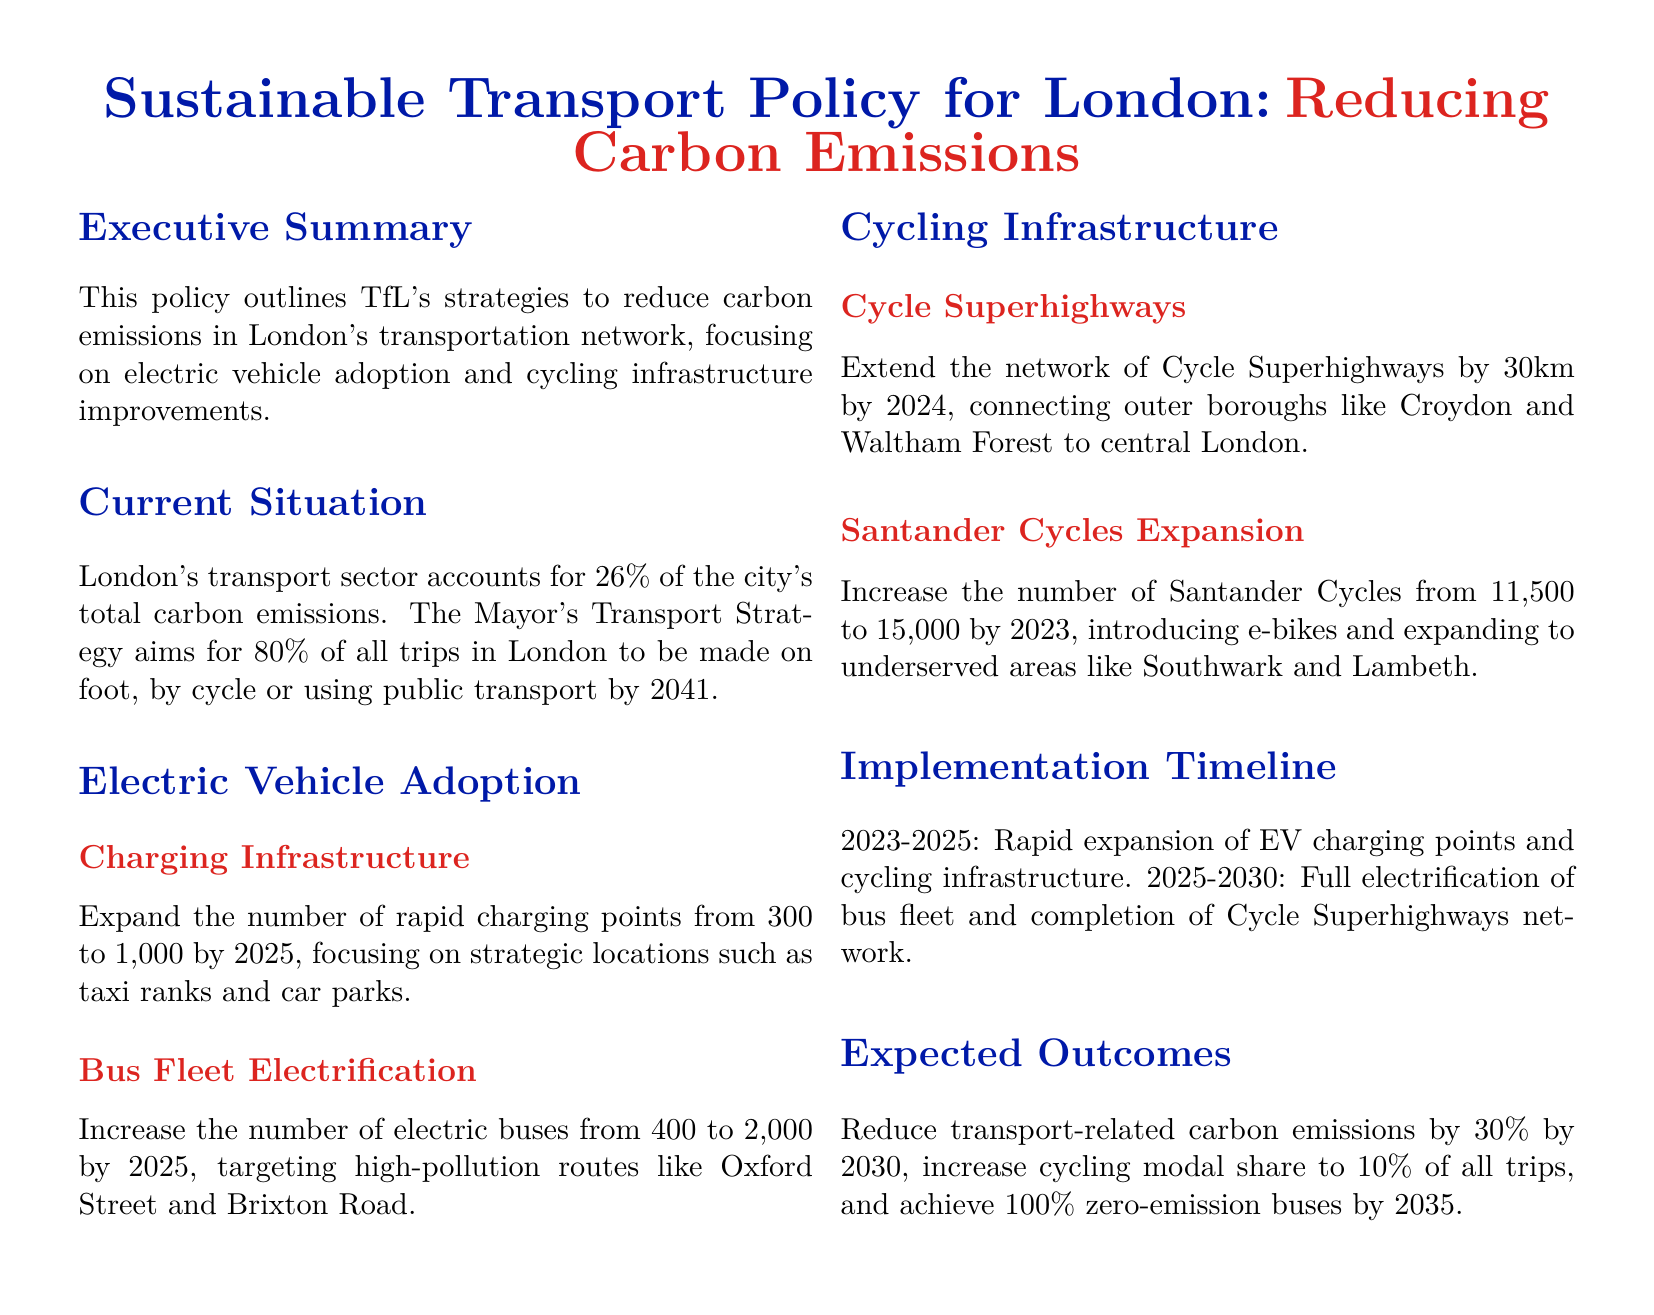What percentage of London's carbon emissions comes from the transport sector? The document states that London's transport sector accounts for 26% of the city's total carbon emissions.
Answer: 26% What is the target for electric buses by 2025? The policy aims to increase the number of electric buses from 400 to 2,000 by 2025.
Answer: 2,000 By how many kilometers will the Cycle Superhighways network be extended by 2024? The document specifies that the Cycle Superhighways network will be extended by 30km by 2024.
Answer: 30km What is the goal for zero-emission buses by 2035? The expected outcome is to achieve 100% zero-emission buses by 2035.
Answer: 100% Which transportation modes does the Mayor's Transport Strategy aim to promote for 80% of all trips by 2041? The document mentions that the goal is for trips in London to be made on foot, by cycle or using public transport.
Answer: Foot, cycle, public transport What year is set for the full electrification of the bus fleet? The implementation timeline indicates that full electrification of the bus fleet will be completed by 2030.
Answer: 2030 How many Santander Cycles are planned to be available by 2023? The document states that the number of Santander Cycles will increase from 11,500 to 15,000 by 2023.
Answer: 15,000 What is the expected reduction in transport-related carbon emissions by 2030? The document states that the aim is to reduce transport-related carbon emissions by 30% by 2030.
Answer: 30% 